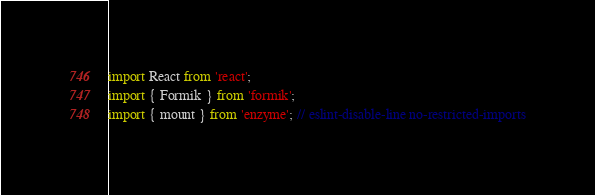Convert code to text. <code><loc_0><loc_0><loc_500><loc_500><_JavaScript_>import React from 'react';
import { Formik } from 'formik';
import { mount } from 'enzyme'; // eslint-disable-line no-restricted-imports</code> 